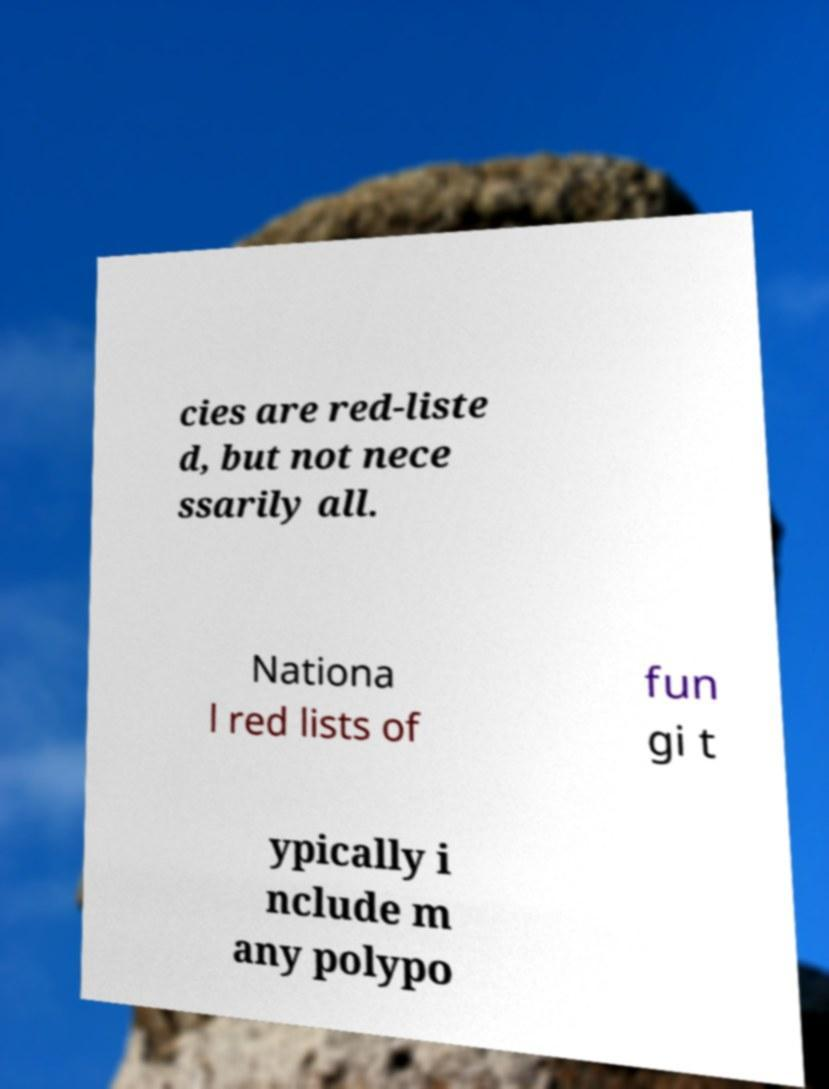Please identify and transcribe the text found in this image. cies are red-liste d, but not nece ssarily all. Nationa l red lists of fun gi t ypically i nclude m any polypo 